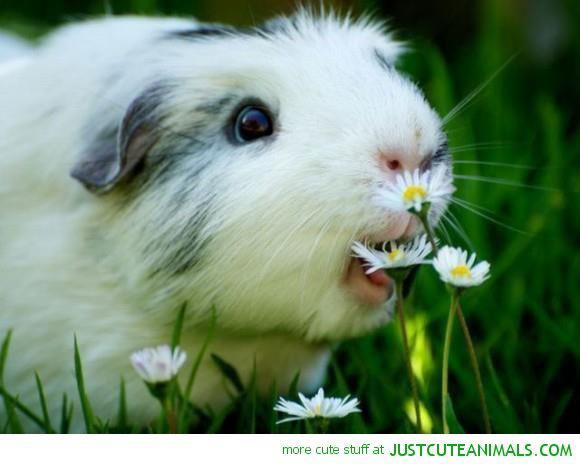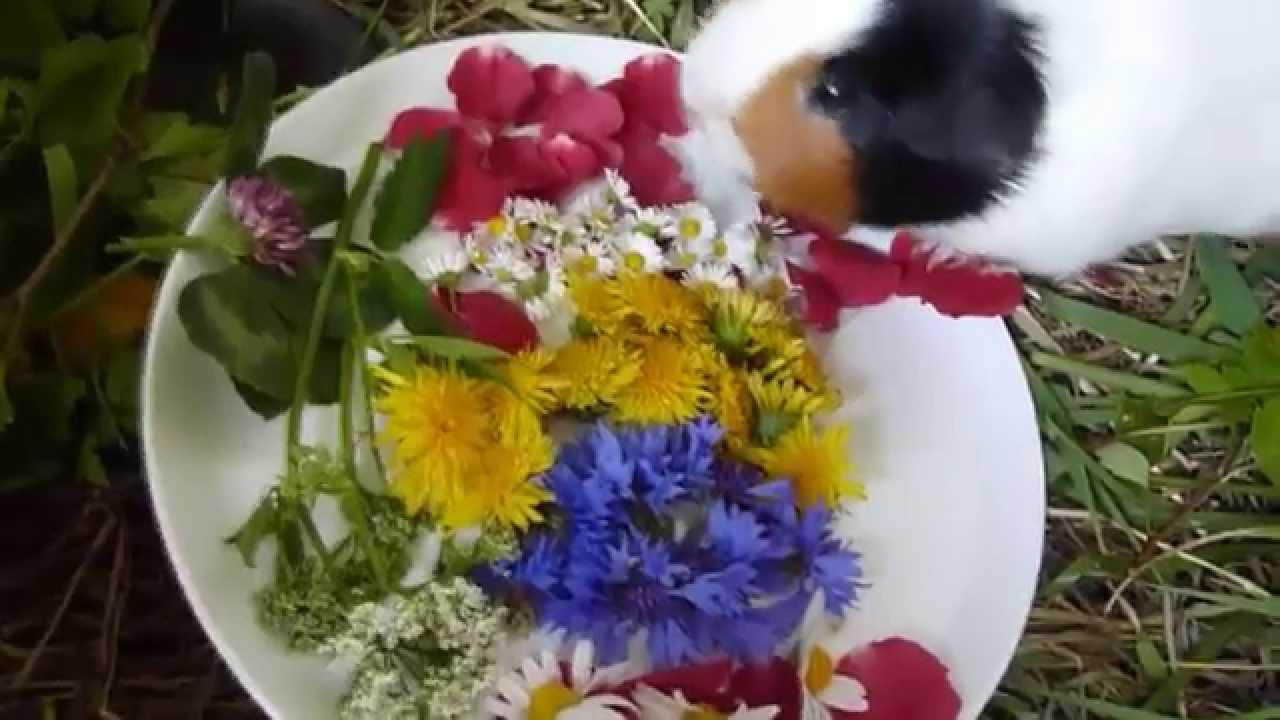The first image is the image on the left, the second image is the image on the right. For the images shown, is this caption "One little animal is wearing a bunch of yellow and white daisies on its head." true? Answer yes or no. No. 